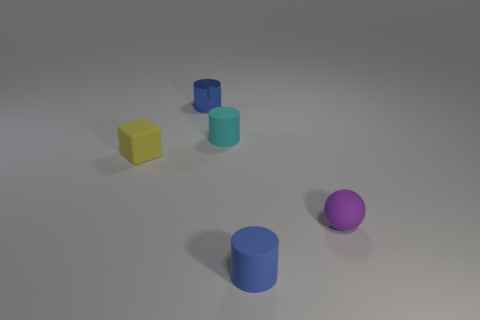Subtract all brown cubes. How many blue cylinders are left? 2 Subtract all matte cylinders. How many cylinders are left? 1 Add 1 large purple balls. How many objects exist? 6 Subtract all cylinders. How many objects are left? 2 Subtract all purple cylinders. Subtract all brown balls. How many cylinders are left? 3 Subtract all cyan rubber cylinders. Subtract all tiny balls. How many objects are left? 3 Add 4 small matte objects. How many small matte objects are left? 8 Add 5 blue metal spheres. How many blue metal spheres exist? 5 Subtract 0 yellow cylinders. How many objects are left? 5 